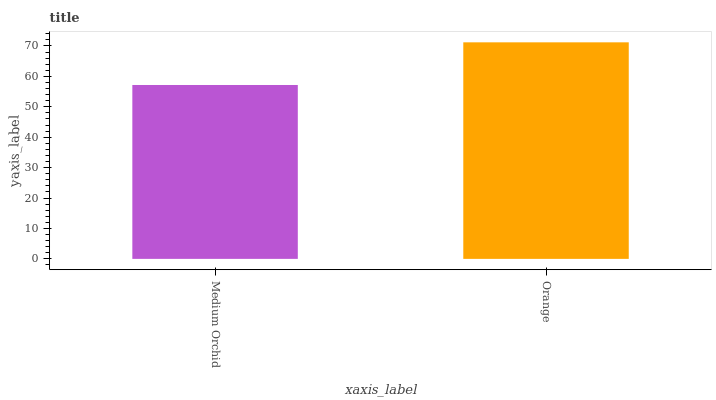Is Orange the minimum?
Answer yes or no. No. Is Orange greater than Medium Orchid?
Answer yes or no. Yes. Is Medium Orchid less than Orange?
Answer yes or no. Yes. Is Medium Orchid greater than Orange?
Answer yes or no. No. Is Orange less than Medium Orchid?
Answer yes or no. No. Is Orange the high median?
Answer yes or no. Yes. Is Medium Orchid the low median?
Answer yes or no. Yes. Is Medium Orchid the high median?
Answer yes or no. No. Is Orange the low median?
Answer yes or no. No. 